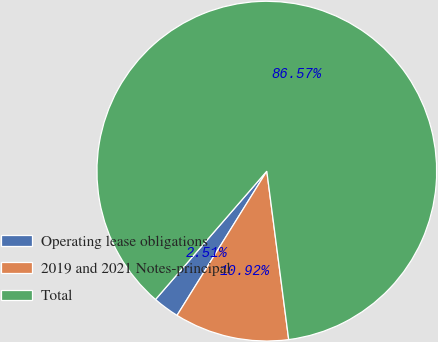Convert chart. <chart><loc_0><loc_0><loc_500><loc_500><pie_chart><fcel>Operating lease obligations<fcel>2019 and 2021 Notes-principal<fcel>Total<nl><fcel>2.51%<fcel>10.92%<fcel>86.57%<nl></chart> 